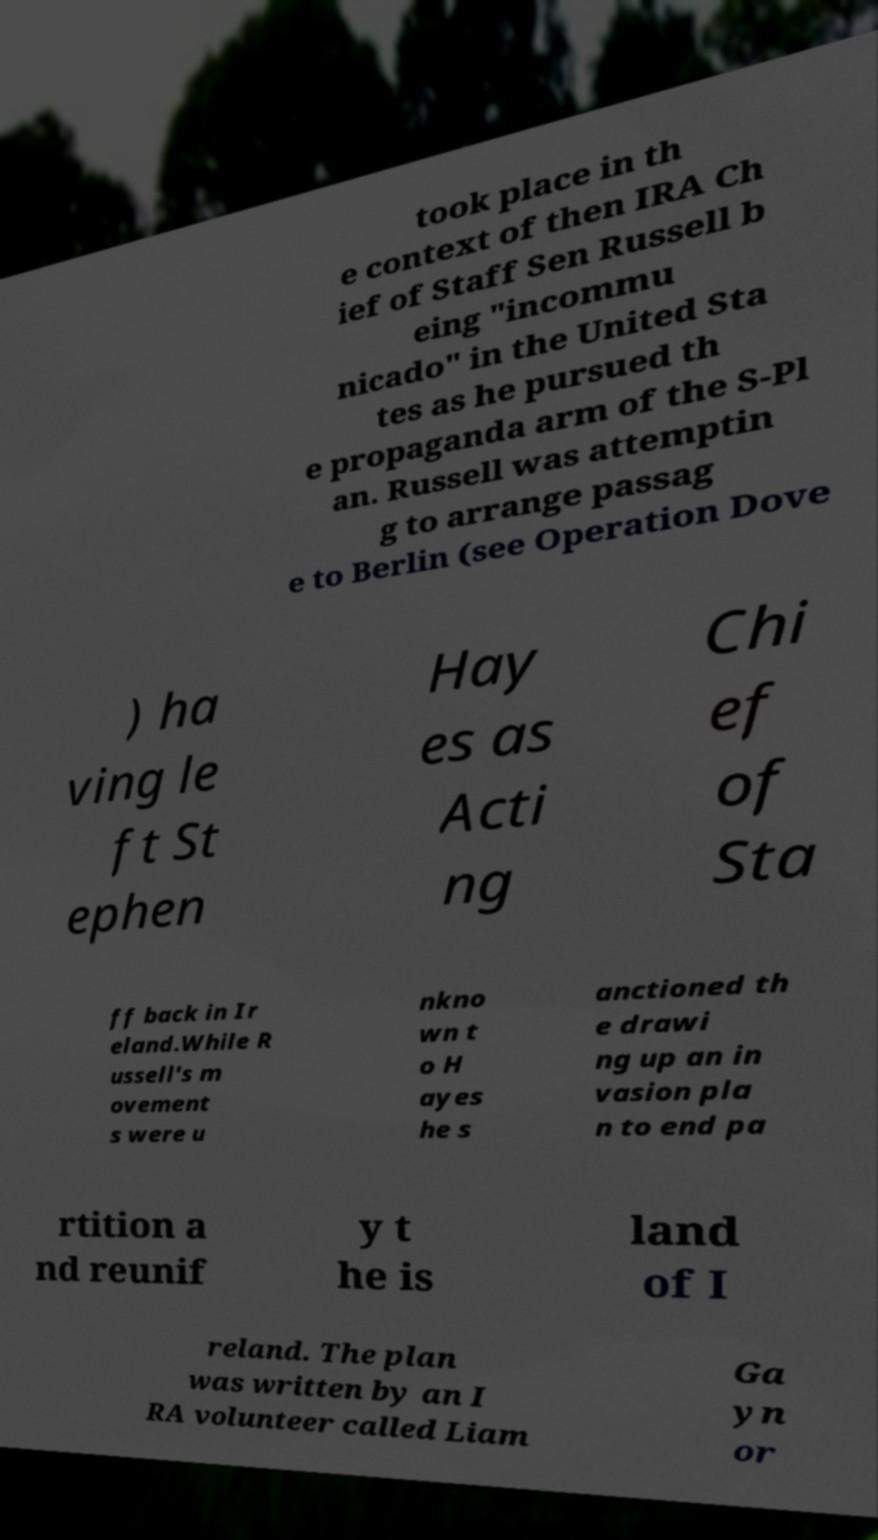Could you extract and type out the text from this image? took place in th e context of then IRA Ch ief of Staff Sen Russell b eing "incommu nicado" in the United Sta tes as he pursued th e propaganda arm of the S-Pl an. Russell was attemptin g to arrange passag e to Berlin (see Operation Dove ) ha ving le ft St ephen Hay es as Acti ng Chi ef of Sta ff back in Ir eland.While R ussell's m ovement s were u nkno wn t o H ayes he s anctioned th e drawi ng up an in vasion pla n to end pa rtition a nd reunif y t he is land of I reland. The plan was written by an I RA volunteer called Liam Ga yn or 